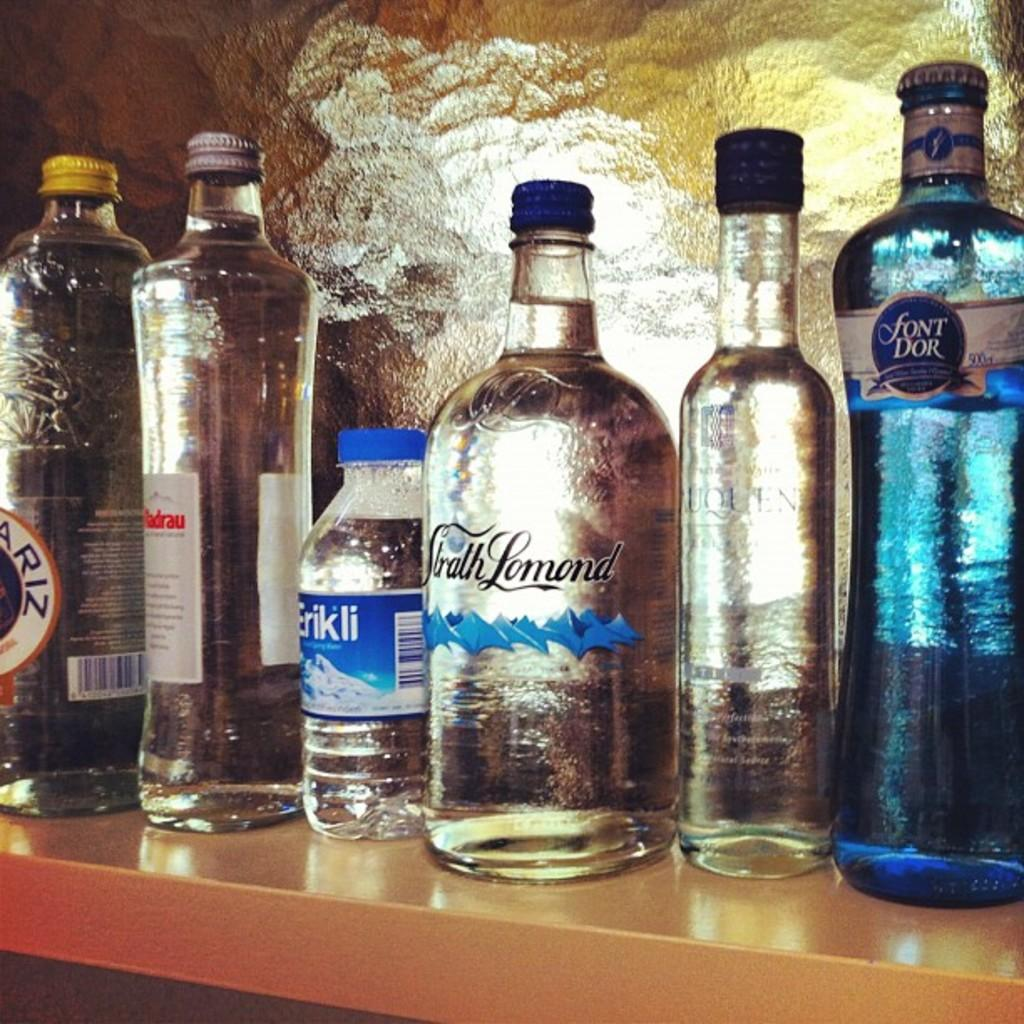<image>
Present a compact description of the photo's key features. Bottles of alcohol with one that says "Font Dor" on it. 